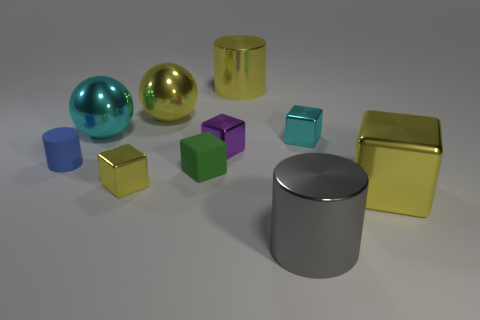Is the number of small blue rubber cylinders on the right side of the yellow sphere less than the number of cyan metal spheres?
Keep it short and to the point. Yes. There is a tiny purple object in front of the cyan shiny cube; what is its material?
Offer a terse response. Metal. What number of other things are the same size as the cyan metal cube?
Make the answer very short. 4. Is the number of cyan rubber things less than the number of tiny metal blocks?
Provide a short and direct response. Yes. The blue matte thing has what shape?
Provide a succinct answer. Cylinder. There is a tiny metallic cube in front of the small blue thing; is its color the same as the small cylinder?
Keep it short and to the point. No. The yellow thing that is both behind the rubber cylinder and to the right of the green rubber cube has what shape?
Provide a short and direct response. Cylinder. There is a big shiny cylinder behind the gray thing; what is its color?
Your answer should be compact. Yellow. Is there any other thing that is the same color as the tiny matte cylinder?
Offer a terse response. No. Do the cyan ball and the cyan cube have the same size?
Your answer should be very brief. No. 